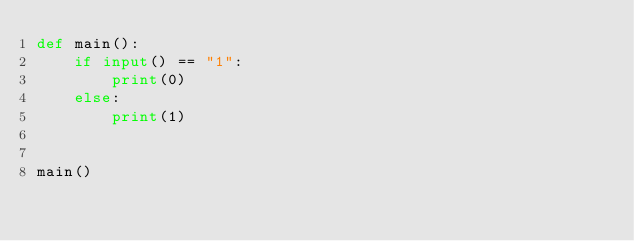Convert code to text. <code><loc_0><loc_0><loc_500><loc_500><_Python_>def main():
    if input() == "1":
        print(0)
    else:
        print(1)


main()
</code> 